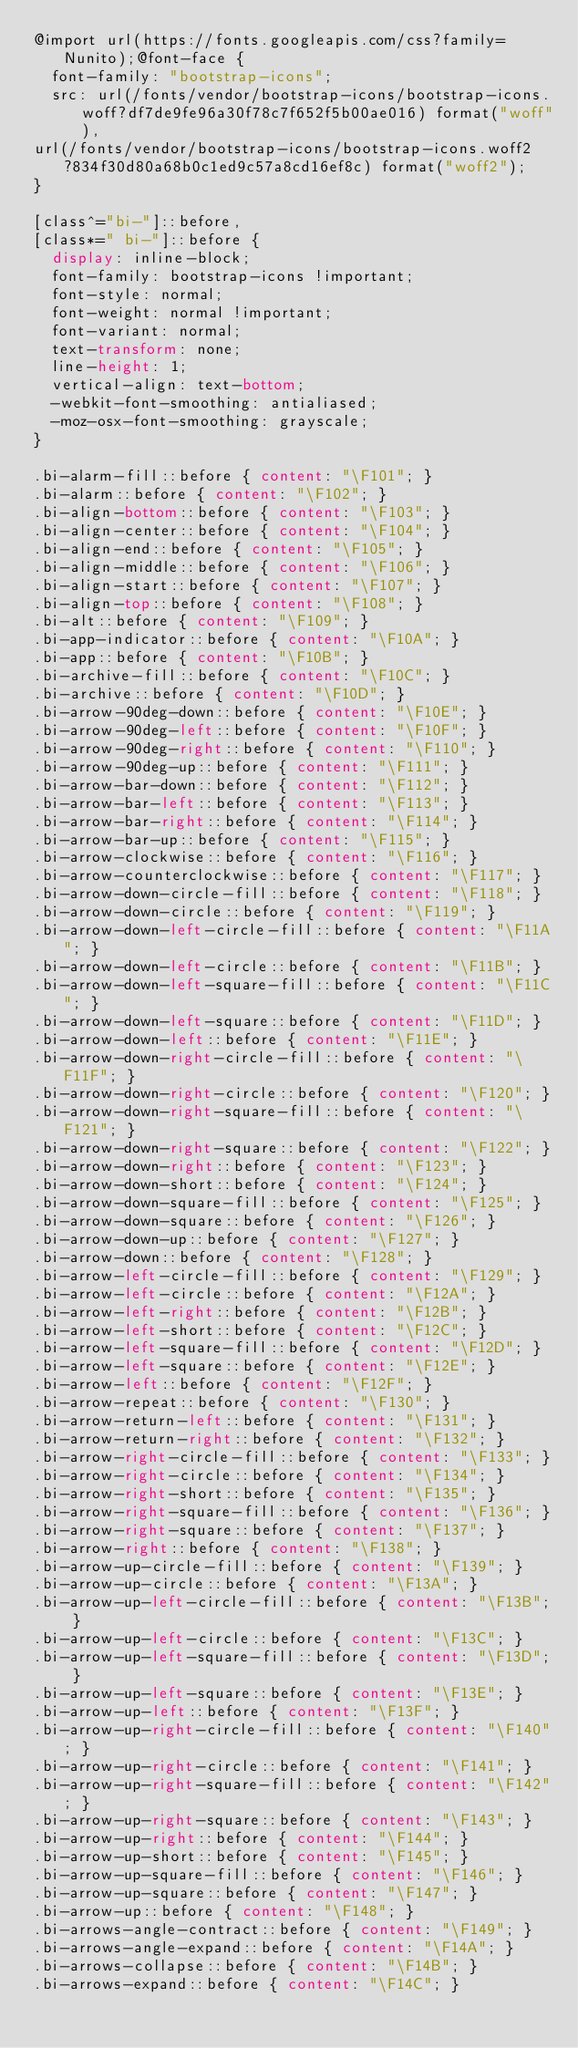<code> <loc_0><loc_0><loc_500><loc_500><_CSS_>@import url(https://fonts.googleapis.com/css?family=Nunito);@font-face {
  font-family: "bootstrap-icons";
  src: url(/fonts/vendor/bootstrap-icons/bootstrap-icons.woff?df7de9fe96a30f78c7f652f5b00ae016) format("woff"),
url(/fonts/vendor/bootstrap-icons/bootstrap-icons.woff2?834f30d80a68b0c1ed9c57a8cd16ef8c) format("woff2");
}

[class^="bi-"]::before,
[class*=" bi-"]::before {
  display: inline-block;
  font-family: bootstrap-icons !important;
  font-style: normal;
  font-weight: normal !important;
  font-variant: normal;
  text-transform: none;
  line-height: 1;
  vertical-align: text-bottom;
  -webkit-font-smoothing: antialiased;
  -moz-osx-font-smoothing: grayscale;
}

.bi-alarm-fill::before { content: "\F101"; }
.bi-alarm::before { content: "\F102"; }
.bi-align-bottom::before { content: "\F103"; }
.bi-align-center::before { content: "\F104"; }
.bi-align-end::before { content: "\F105"; }
.bi-align-middle::before { content: "\F106"; }
.bi-align-start::before { content: "\F107"; }
.bi-align-top::before { content: "\F108"; }
.bi-alt::before { content: "\F109"; }
.bi-app-indicator::before { content: "\F10A"; }
.bi-app::before { content: "\F10B"; }
.bi-archive-fill::before { content: "\F10C"; }
.bi-archive::before { content: "\F10D"; }
.bi-arrow-90deg-down::before { content: "\F10E"; }
.bi-arrow-90deg-left::before { content: "\F10F"; }
.bi-arrow-90deg-right::before { content: "\F110"; }
.bi-arrow-90deg-up::before { content: "\F111"; }
.bi-arrow-bar-down::before { content: "\F112"; }
.bi-arrow-bar-left::before { content: "\F113"; }
.bi-arrow-bar-right::before { content: "\F114"; }
.bi-arrow-bar-up::before { content: "\F115"; }
.bi-arrow-clockwise::before { content: "\F116"; }
.bi-arrow-counterclockwise::before { content: "\F117"; }
.bi-arrow-down-circle-fill::before { content: "\F118"; }
.bi-arrow-down-circle::before { content: "\F119"; }
.bi-arrow-down-left-circle-fill::before { content: "\F11A"; }
.bi-arrow-down-left-circle::before { content: "\F11B"; }
.bi-arrow-down-left-square-fill::before { content: "\F11C"; }
.bi-arrow-down-left-square::before { content: "\F11D"; }
.bi-arrow-down-left::before { content: "\F11E"; }
.bi-arrow-down-right-circle-fill::before { content: "\F11F"; }
.bi-arrow-down-right-circle::before { content: "\F120"; }
.bi-arrow-down-right-square-fill::before { content: "\F121"; }
.bi-arrow-down-right-square::before { content: "\F122"; }
.bi-arrow-down-right::before { content: "\F123"; }
.bi-arrow-down-short::before { content: "\F124"; }
.bi-arrow-down-square-fill::before { content: "\F125"; }
.bi-arrow-down-square::before { content: "\F126"; }
.bi-arrow-down-up::before { content: "\F127"; }
.bi-arrow-down::before { content: "\F128"; }
.bi-arrow-left-circle-fill::before { content: "\F129"; }
.bi-arrow-left-circle::before { content: "\F12A"; }
.bi-arrow-left-right::before { content: "\F12B"; }
.bi-arrow-left-short::before { content: "\F12C"; }
.bi-arrow-left-square-fill::before { content: "\F12D"; }
.bi-arrow-left-square::before { content: "\F12E"; }
.bi-arrow-left::before { content: "\F12F"; }
.bi-arrow-repeat::before { content: "\F130"; }
.bi-arrow-return-left::before { content: "\F131"; }
.bi-arrow-return-right::before { content: "\F132"; }
.bi-arrow-right-circle-fill::before { content: "\F133"; }
.bi-arrow-right-circle::before { content: "\F134"; }
.bi-arrow-right-short::before { content: "\F135"; }
.bi-arrow-right-square-fill::before { content: "\F136"; }
.bi-arrow-right-square::before { content: "\F137"; }
.bi-arrow-right::before { content: "\F138"; }
.bi-arrow-up-circle-fill::before { content: "\F139"; }
.bi-arrow-up-circle::before { content: "\F13A"; }
.bi-arrow-up-left-circle-fill::before { content: "\F13B"; }
.bi-arrow-up-left-circle::before { content: "\F13C"; }
.bi-arrow-up-left-square-fill::before { content: "\F13D"; }
.bi-arrow-up-left-square::before { content: "\F13E"; }
.bi-arrow-up-left::before { content: "\F13F"; }
.bi-arrow-up-right-circle-fill::before { content: "\F140"; }
.bi-arrow-up-right-circle::before { content: "\F141"; }
.bi-arrow-up-right-square-fill::before { content: "\F142"; }
.bi-arrow-up-right-square::before { content: "\F143"; }
.bi-arrow-up-right::before { content: "\F144"; }
.bi-arrow-up-short::before { content: "\F145"; }
.bi-arrow-up-square-fill::before { content: "\F146"; }
.bi-arrow-up-square::before { content: "\F147"; }
.bi-arrow-up::before { content: "\F148"; }
.bi-arrows-angle-contract::before { content: "\F149"; }
.bi-arrows-angle-expand::before { content: "\F14A"; }
.bi-arrows-collapse::before { content: "\F14B"; }
.bi-arrows-expand::before { content: "\F14C"; }</code> 